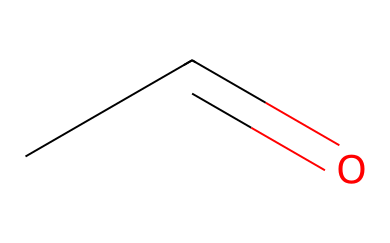What is the common name of CC=O? The SMILES representation "CC=O" corresponds to acetaldehyde, which is a common name for the chemical as it consists of a two-carbon chain with an aldehyde functional group.
Answer: acetaldehyde How many carbon atoms are in acetaldehyde? By analyzing the SMILES structure "CC=O," we can see that there are two 'C' characters, indicating the presence of two carbon atoms in the molecule.
Answer: 2 What type of functional group is present in acetaldehyde? The "C=O" part of the SMILES denotes the presence of a carbonyl functional group. Since this carbonyl is at the end of the carbon chain, it indicates that acetaldehyde is an aldehyde.
Answer: aldehyde How many hydrogen atoms can be inferred from the structure of acetaldehyde? In acetaldehyde (CC=O), each carbon (C) can typically bond with enough hydrogens to fulfill the tetravalent nature of carbon. Here, one carbon is part of the aldehyde and binds to one hydrogen, while the other is bonded to three hydrogens, giving a total of four hydrogens.
Answer: 4 What makes acetaldehyde an important substance in synthetic turf materials? Acetaldehyde is often used in the synthesis of various chemicals, including those used in the production of synthetic materials. It serves as an intermediate in making polymers and other compounds that may be used in turf materials.
Answer: important intermediate 